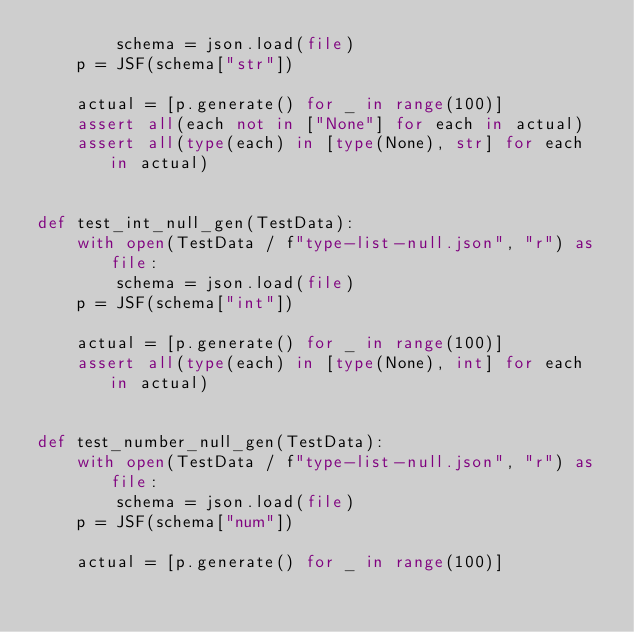Convert code to text. <code><loc_0><loc_0><loc_500><loc_500><_Python_>        schema = json.load(file)
    p = JSF(schema["str"])

    actual = [p.generate() for _ in range(100)]
    assert all(each not in ["None"] for each in actual)
    assert all(type(each) in [type(None), str] for each in actual)


def test_int_null_gen(TestData):
    with open(TestData / f"type-list-null.json", "r") as file:
        schema = json.load(file)
    p = JSF(schema["int"])

    actual = [p.generate() for _ in range(100)]
    assert all(type(each) in [type(None), int] for each in actual)


def test_number_null_gen(TestData):
    with open(TestData / f"type-list-null.json", "r") as file:
        schema = json.load(file)
    p = JSF(schema["num"])

    actual = [p.generate() for _ in range(100)]</code> 